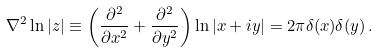Convert formula to latex. <formula><loc_0><loc_0><loc_500><loc_500>\nabla ^ { 2 } \ln | z | \equiv \left ( \frac { \partial ^ { 2 } } { \partial x ^ { 2 } } + \frac { \partial ^ { 2 } } { \partial y ^ { 2 } } \right ) \ln | x + i y | = 2 \pi \delta ( x ) \delta ( y ) \, .</formula> 